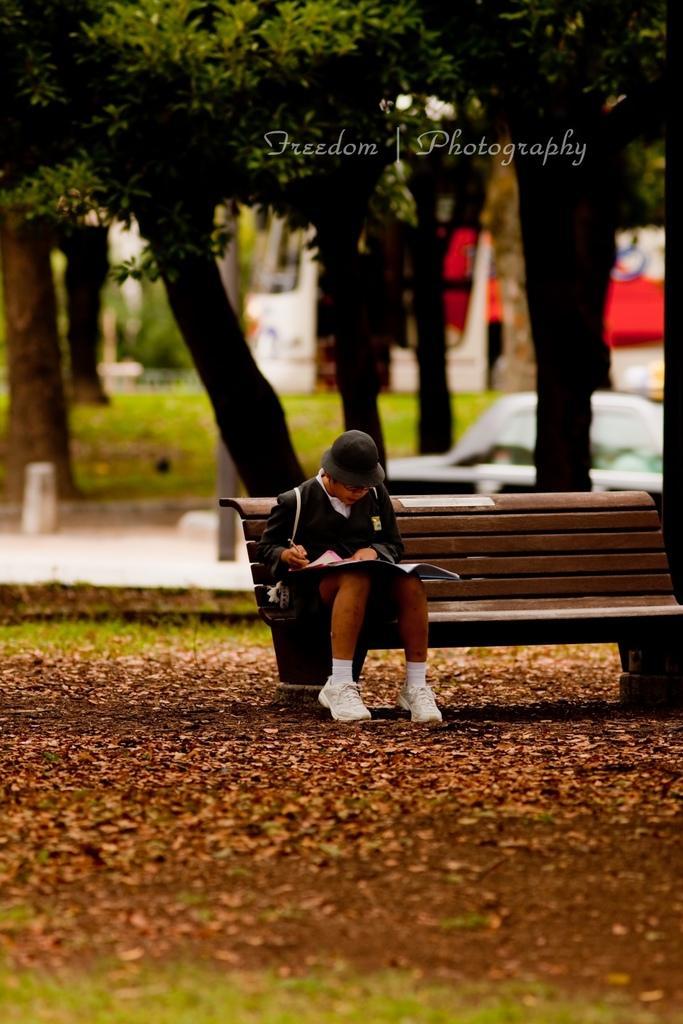Describe this image in one or two sentences. On the background we can see trees, vehicle and a grass. Here we can see one person sitting on bench , holding a pen in hand and there is a book. Here we can see dried leaves. 